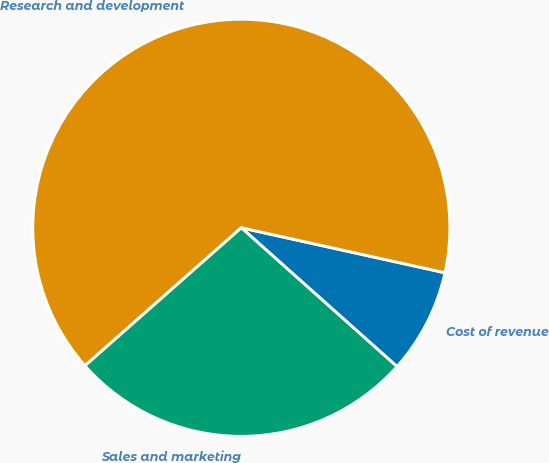Convert chart to OTSL. <chart><loc_0><loc_0><loc_500><loc_500><pie_chart><fcel>Cost of revenue<fcel>Research and development<fcel>Sales and marketing<nl><fcel>8.13%<fcel>64.97%<fcel>26.9%<nl></chart> 